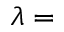<formula> <loc_0><loc_0><loc_500><loc_500>\lambda =</formula> 